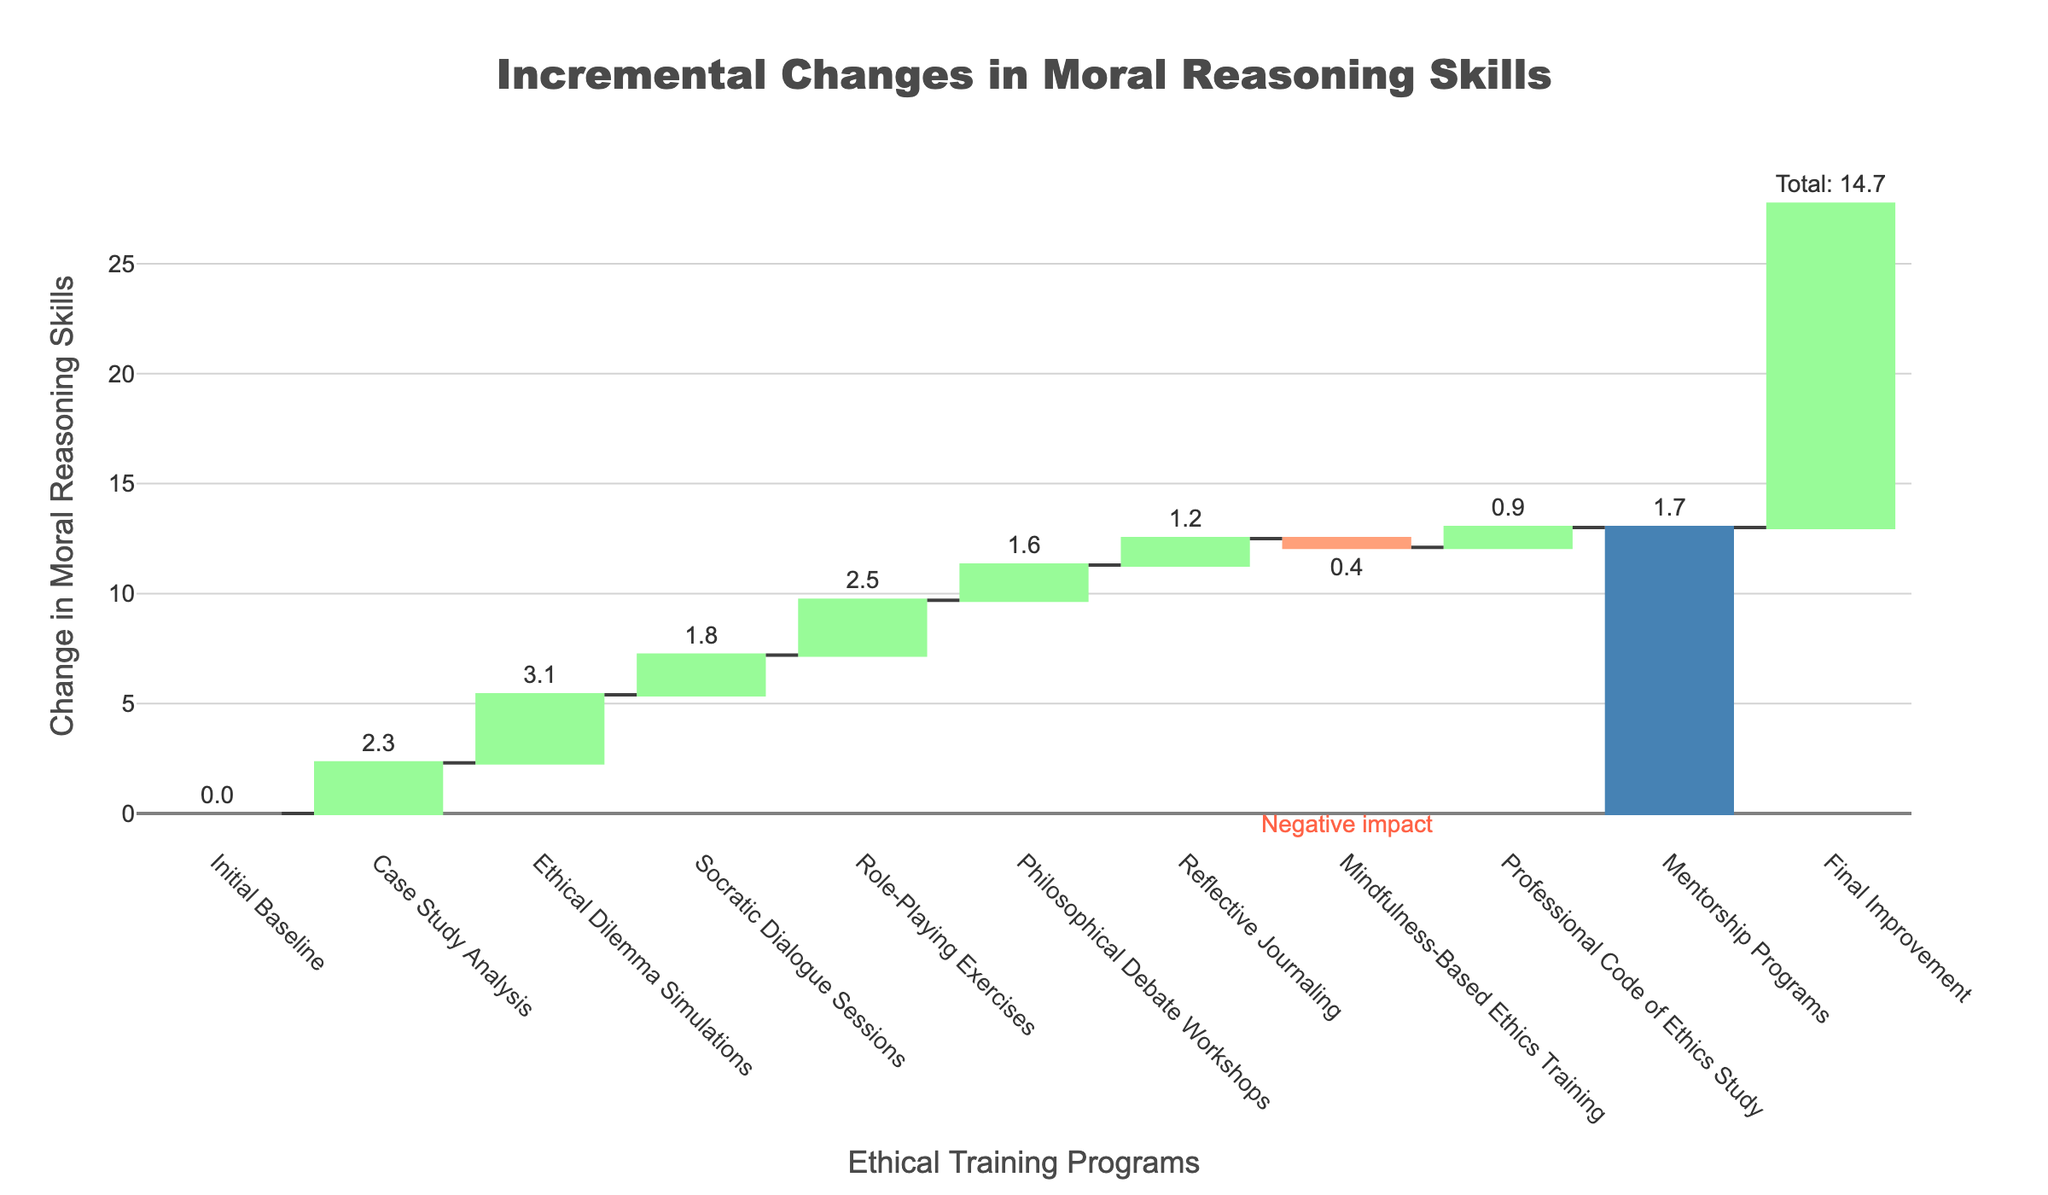What is the title of the figure? The title is located at the top of the chart. It reads "Incremental Changes in Moral Reasoning Skills."
Answer: Incremental Changes in Moral Reasoning Skills What is the overall change listed at the end of the chart? The total change is indicated at the end of the chart. It shows a final improvement of 14.7.
Answer: 14.7 Which training method shows the highest increase in moral reasoning skills? Look at the bar that increases the most compared to others. "Ethical Dilemma Simulations" show an increase of 3.1.
Answer: Ethical Dilemma Simulations What is the change observed with the Mindfulness-Based Ethics Training? The bar for "Mindfulness-Based Ethics Training" shows the change. It indicates a decrease, highlighted in a different color. The change is -0.4.
Answer: -0.4 How many training methods resulted in an increase in moral reasoning skills? Count the bars showing positive changes. There are 9 training methods with positive changes.
Answer: 9 By how much did Case Study Analysis improve moral reasoning skills? Refer to the bar for "Case Study Analysis." It shows an increase of 2.3.
Answer: 2.3 Which training methods led to less than a 2.0 increase in moral reasoning skills? Identify the bars with a height less than 2.0. "Socratic Dialogue Sessions," "Philosophical Debate Workshops," "Reflective Journaling," "Mindfulness-Based Ethics Training," and "Professional Code of Ethics Study" fall into this category.
Answer: Socratic Dialogue Sessions, Philosophical Debate Workshops, Reflective Journaling, Mindfulness-Based Ethics Training, Professional Code of Ethics Study Which training method caused a negative impact on moral reasoning skills? There is only one bar below the zero line, indicating the negative impact. It is "Mindfulness-Based Ethics Training" with a change of -0.4.
Answer: Mindfulness-Based Ethics Training What is the combined change from both Role-Playing Exercises and Mentorship Programs? Add the changes from "Role-Playing Exercises" and "Mentorship Programs" together. It is 2.5 + 1.7 = 4.2.
Answer: 4.2 